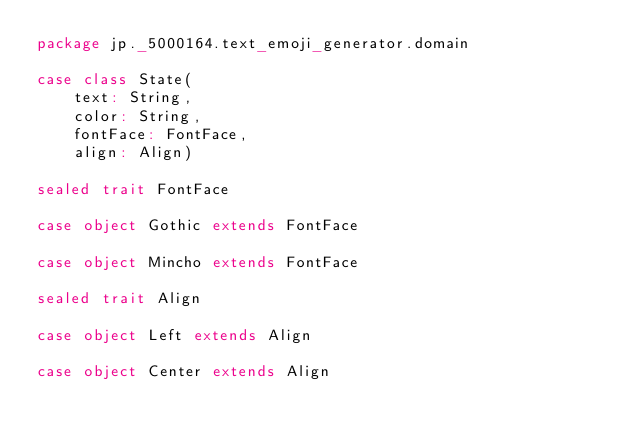Convert code to text. <code><loc_0><loc_0><loc_500><loc_500><_Scala_>package jp._5000164.text_emoji_generator.domain

case class State(
    text: String,
    color: String,
    fontFace: FontFace,
    align: Align)

sealed trait FontFace

case object Gothic extends FontFace

case object Mincho extends FontFace

sealed trait Align

case object Left extends Align

case object Center extends Align
</code> 